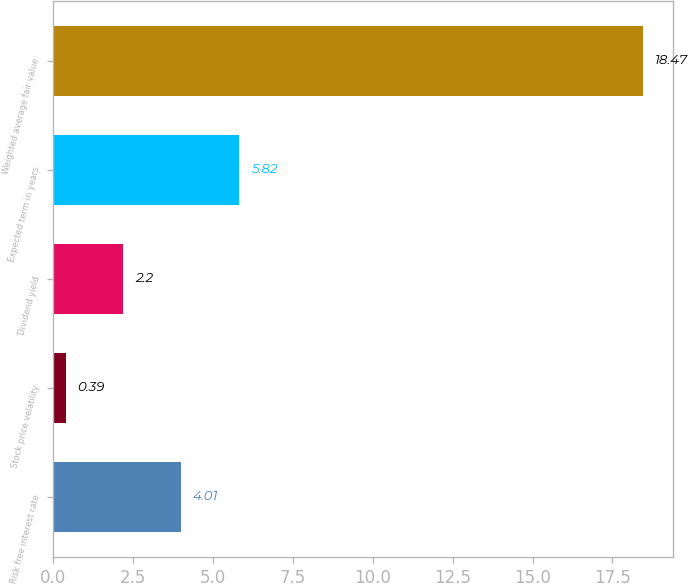Convert chart to OTSL. <chart><loc_0><loc_0><loc_500><loc_500><bar_chart><fcel>Risk free interest rate<fcel>Stock price volatility<fcel>Dividend yield<fcel>Expected term in years<fcel>Weighted average fair value<nl><fcel>4.01<fcel>0.39<fcel>2.2<fcel>5.82<fcel>18.47<nl></chart> 